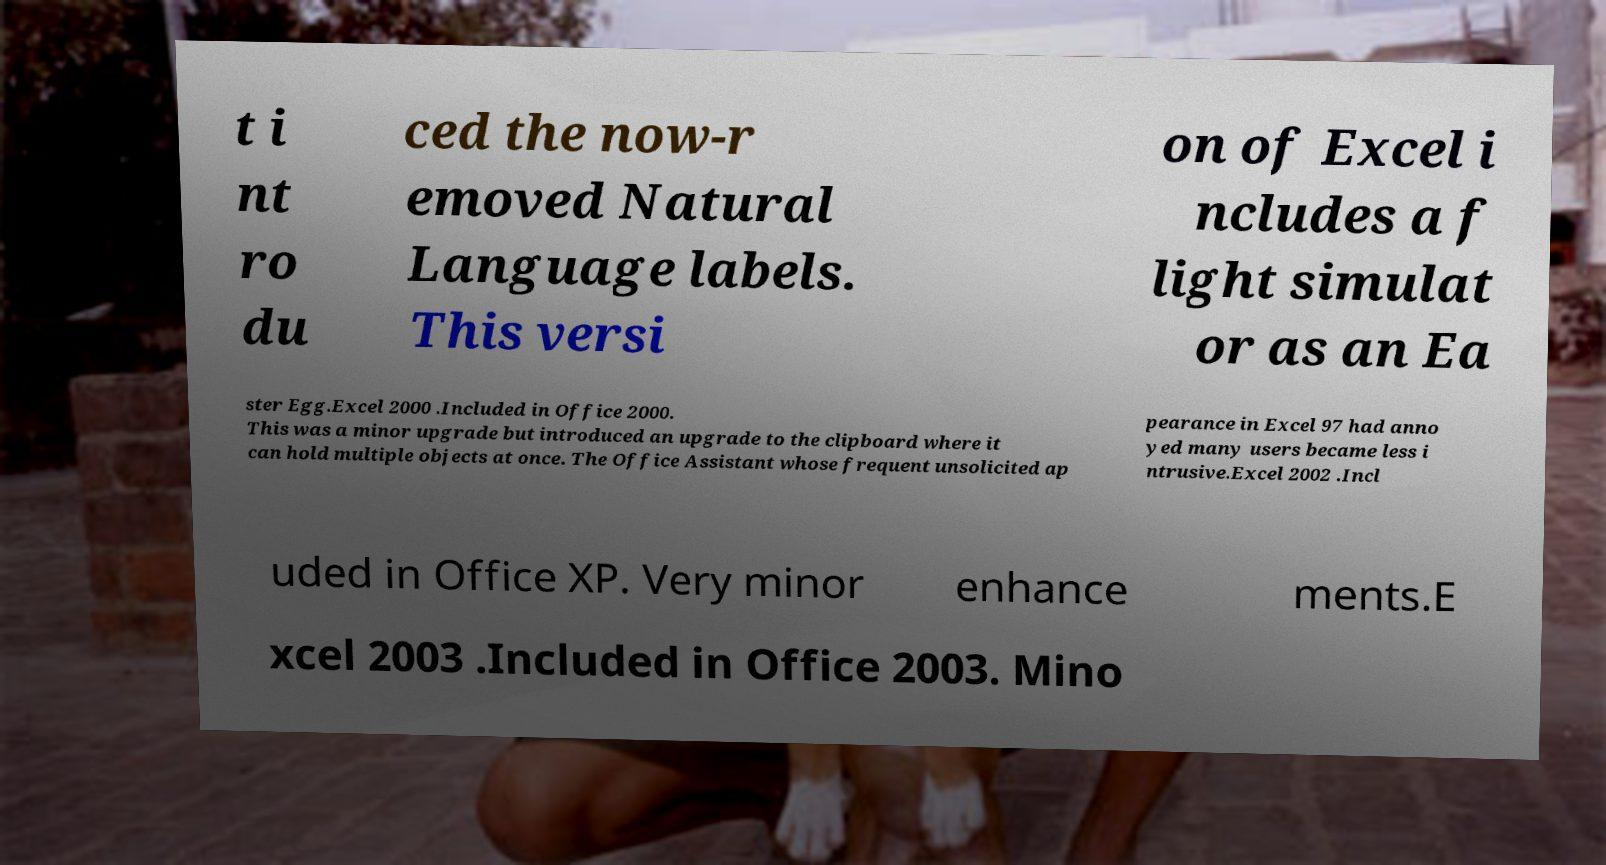For documentation purposes, I need the text within this image transcribed. Could you provide that? t i nt ro du ced the now-r emoved Natural Language labels. This versi on of Excel i ncludes a f light simulat or as an Ea ster Egg.Excel 2000 .Included in Office 2000. This was a minor upgrade but introduced an upgrade to the clipboard where it can hold multiple objects at once. The Office Assistant whose frequent unsolicited ap pearance in Excel 97 had anno yed many users became less i ntrusive.Excel 2002 .Incl uded in Office XP. Very minor enhance ments.E xcel 2003 .Included in Office 2003. Mino 